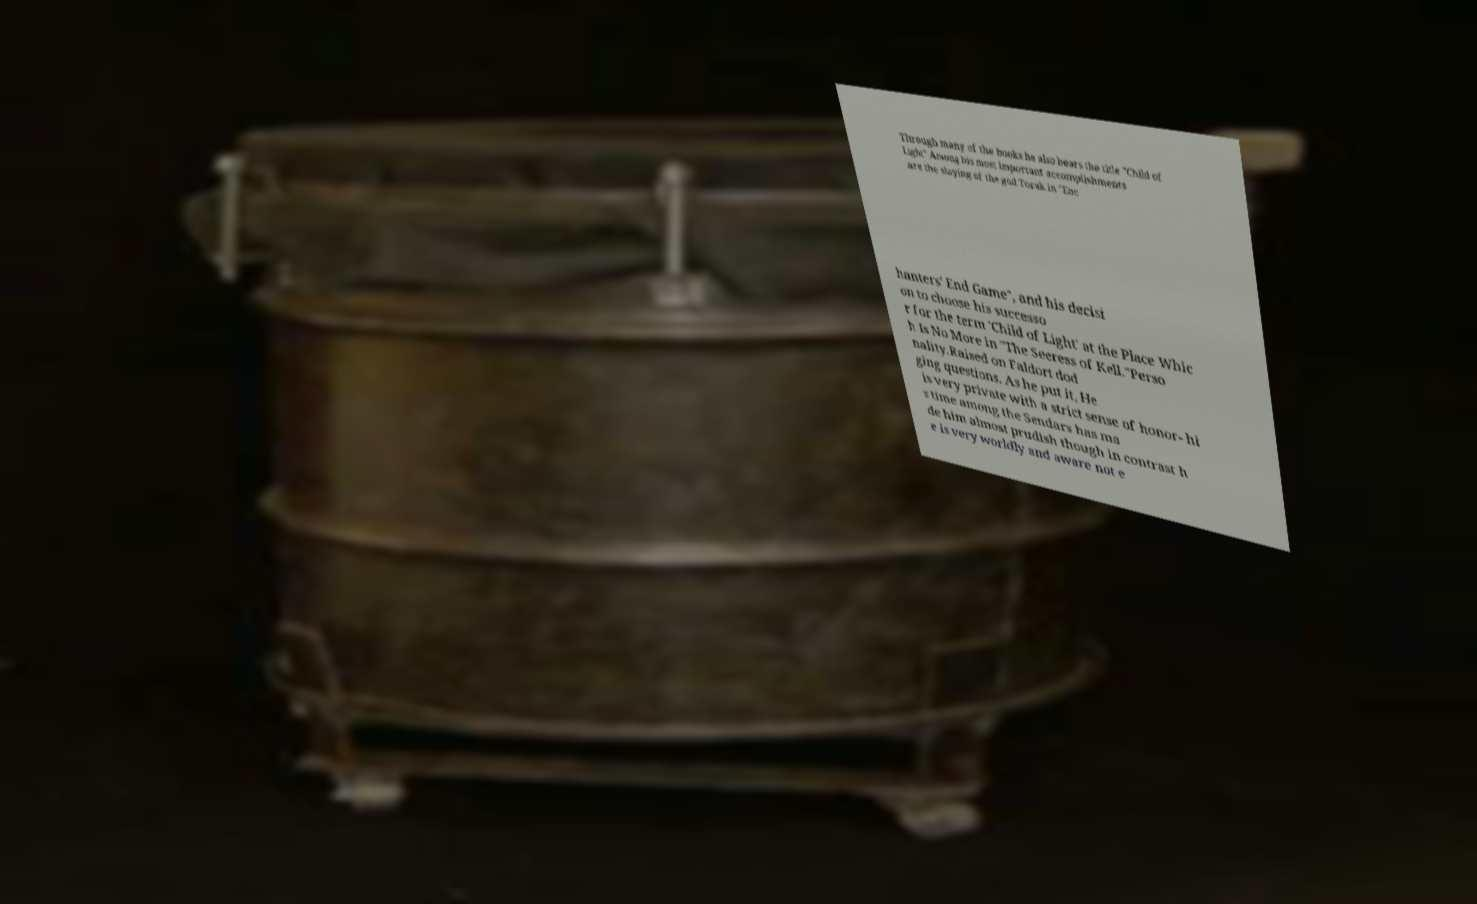For documentation purposes, I need the text within this image transcribed. Could you provide that? Through many of the books he also bears the title "Child of Light" Among his most important accomplishments are the slaying of the god Torak in "Enc hanters' End Game", and his decisi on to choose his successo r for the term 'Child of Light' at the Place Whic h Is No More in "The Seeress of Kell."Perso nality.Raised on Faldort dod ging questions. As he put it, He is very private with a strict sense of honor- hi s time among the Sendars has ma de him almost prudish though in contrast h e is very worldly and aware not e 